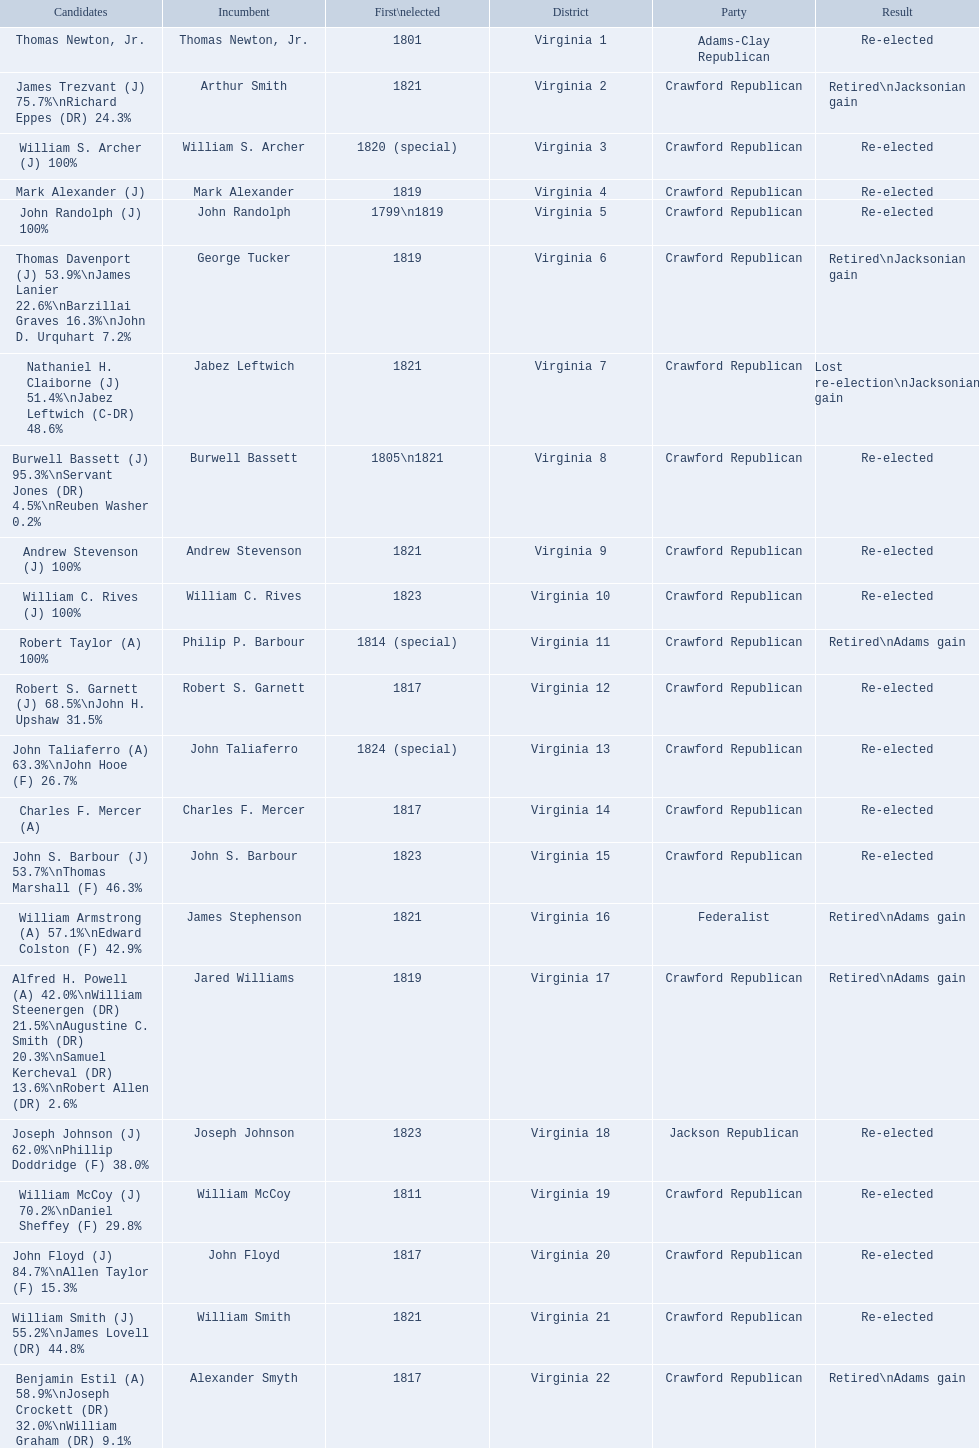Who were the incumbents of the 1824 united states house of representatives elections? Thomas Newton, Jr., Arthur Smith, William S. Archer, Mark Alexander, John Randolph, George Tucker, Jabez Leftwich, Burwell Bassett, Andrew Stevenson, William C. Rives, Philip P. Barbour, Robert S. Garnett, John Taliaferro, Charles F. Mercer, John S. Barbour, James Stephenson, Jared Williams, Joseph Johnson, William McCoy, John Floyd, William Smith, Alexander Smyth. And who were the candidates? Thomas Newton, Jr., James Trezvant (J) 75.7%\nRichard Eppes (DR) 24.3%, William S. Archer (J) 100%, Mark Alexander (J), John Randolph (J) 100%, Thomas Davenport (J) 53.9%\nJames Lanier 22.6%\nBarzillai Graves 16.3%\nJohn D. Urquhart 7.2%, Nathaniel H. Claiborne (J) 51.4%\nJabez Leftwich (C-DR) 48.6%, Burwell Bassett (J) 95.3%\nServant Jones (DR) 4.5%\nReuben Washer 0.2%, Andrew Stevenson (J) 100%, William C. Rives (J) 100%, Robert Taylor (A) 100%, Robert S. Garnett (J) 68.5%\nJohn H. Upshaw 31.5%, John Taliaferro (A) 63.3%\nJohn Hooe (F) 26.7%, Charles F. Mercer (A), John S. Barbour (J) 53.7%\nThomas Marshall (F) 46.3%, William Armstrong (A) 57.1%\nEdward Colston (F) 42.9%, Alfred H. Powell (A) 42.0%\nWilliam Steenergen (DR) 21.5%\nAugustine C. Smith (DR) 20.3%\nSamuel Kercheval (DR) 13.6%\nRobert Allen (DR) 2.6%, Joseph Johnson (J) 62.0%\nPhillip Doddridge (F) 38.0%, William McCoy (J) 70.2%\nDaniel Sheffey (F) 29.8%, John Floyd (J) 84.7%\nAllen Taylor (F) 15.3%, William Smith (J) 55.2%\nJames Lovell (DR) 44.8%, Benjamin Estil (A) 58.9%\nJoseph Crockett (DR) 32.0%\nWilliam Graham (DR) 9.1%. What were the results of their elections? Re-elected, Retired\nJacksonian gain, Re-elected, Re-elected, Re-elected, Retired\nJacksonian gain, Lost re-election\nJacksonian gain, Re-elected, Re-elected, Re-elected, Retired\nAdams gain, Re-elected, Re-elected, Re-elected, Re-elected, Retired\nAdams gain, Retired\nAdams gain, Re-elected, Re-elected, Re-elected, Re-elected, Retired\nAdams gain. Give me the full table as a dictionary. {'header': ['Candidates', 'Incumbent', 'First\\nelected', 'District', 'Party', 'Result'], 'rows': [['Thomas Newton, Jr.', 'Thomas Newton, Jr.', '1801', 'Virginia 1', 'Adams-Clay Republican', 'Re-elected'], ['James Trezvant (J) 75.7%\\nRichard Eppes (DR) 24.3%', 'Arthur Smith', '1821', 'Virginia 2', 'Crawford Republican', 'Retired\\nJacksonian gain'], ['William S. Archer (J) 100%', 'William S. Archer', '1820 (special)', 'Virginia 3', 'Crawford Republican', 'Re-elected'], ['Mark Alexander (J)', 'Mark Alexander', '1819', 'Virginia 4', 'Crawford Republican', 'Re-elected'], ['John Randolph (J) 100%', 'John Randolph', '1799\\n1819', 'Virginia 5', 'Crawford Republican', 'Re-elected'], ['Thomas Davenport (J) 53.9%\\nJames Lanier 22.6%\\nBarzillai Graves 16.3%\\nJohn D. Urquhart 7.2%', 'George Tucker', '1819', 'Virginia 6', 'Crawford Republican', 'Retired\\nJacksonian gain'], ['Nathaniel H. Claiborne (J) 51.4%\\nJabez Leftwich (C-DR) 48.6%', 'Jabez Leftwich', '1821', 'Virginia 7', 'Crawford Republican', 'Lost re-election\\nJacksonian gain'], ['Burwell Bassett (J) 95.3%\\nServant Jones (DR) 4.5%\\nReuben Washer 0.2%', 'Burwell Bassett', '1805\\n1821', 'Virginia 8', 'Crawford Republican', 'Re-elected'], ['Andrew Stevenson (J) 100%', 'Andrew Stevenson', '1821', 'Virginia 9', 'Crawford Republican', 'Re-elected'], ['William C. Rives (J) 100%', 'William C. Rives', '1823', 'Virginia 10', 'Crawford Republican', 'Re-elected'], ['Robert Taylor (A) 100%', 'Philip P. Barbour', '1814 (special)', 'Virginia 11', 'Crawford Republican', 'Retired\\nAdams gain'], ['Robert S. Garnett (J) 68.5%\\nJohn H. Upshaw 31.5%', 'Robert S. Garnett', '1817', 'Virginia 12', 'Crawford Republican', 'Re-elected'], ['John Taliaferro (A) 63.3%\\nJohn Hooe (F) 26.7%', 'John Taliaferro', '1824 (special)', 'Virginia 13', 'Crawford Republican', 'Re-elected'], ['Charles F. Mercer (A)', 'Charles F. Mercer', '1817', 'Virginia 14', 'Crawford Republican', 'Re-elected'], ['John S. Barbour (J) 53.7%\\nThomas Marshall (F) 46.3%', 'John S. Barbour', '1823', 'Virginia 15', 'Crawford Republican', 'Re-elected'], ['William Armstrong (A) 57.1%\\nEdward Colston (F) 42.9%', 'James Stephenson', '1821', 'Virginia 16', 'Federalist', 'Retired\\nAdams gain'], ['Alfred H. Powell (A) 42.0%\\nWilliam Steenergen (DR) 21.5%\\nAugustine C. Smith (DR) 20.3%\\nSamuel Kercheval (DR) 13.6%\\nRobert Allen (DR) 2.6%', 'Jared Williams', '1819', 'Virginia 17', 'Crawford Republican', 'Retired\\nAdams gain'], ['Joseph Johnson (J) 62.0%\\nPhillip Doddridge (F) 38.0%', 'Joseph Johnson', '1823', 'Virginia 18', 'Jackson Republican', 'Re-elected'], ['William McCoy (J) 70.2%\\nDaniel Sheffey (F) 29.8%', 'William McCoy', '1811', 'Virginia 19', 'Crawford Republican', 'Re-elected'], ['John Floyd (J) 84.7%\\nAllen Taylor (F) 15.3%', 'John Floyd', '1817', 'Virginia 20', 'Crawford Republican', 'Re-elected'], ['William Smith (J) 55.2%\\nJames Lovell (DR) 44.8%', 'William Smith', '1821', 'Virginia 21', 'Crawford Republican', 'Re-elected'], ['Benjamin Estil (A) 58.9%\\nJoseph Crockett (DR) 32.0%\\nWilliam Graham (DR) 9.1%', 'Alexander Smyth', '1817', 'Virginia 22', 'Crawford Republican', 'Retired\\nAdams gain']]} And which jacksonian won over 76%? Arthur Smith. 